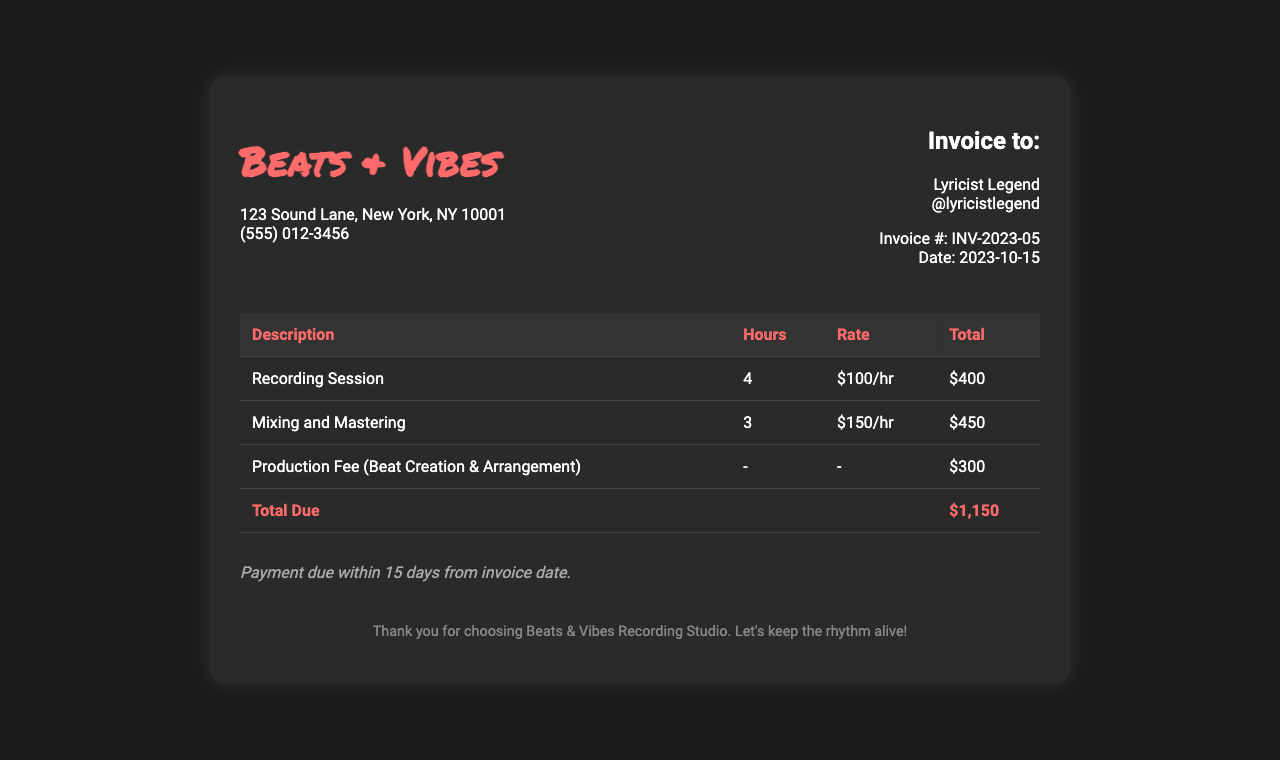What is the name of the studio? The name of the studio is located in the header section of the document.
Answer: Beats & Vibes Who is the invoice addressed to? The invoice recipient is mentioned in the client information section.
Answer: Lyricist Legend How many hours were booked for the recording session? The number of hours for the recording session is listed in the table under 'Hours'.
Answer: 4 What is the hourly rate for mixing and mastering? The rate is specified in the corresponding table cell for that service.
Answer: $150/hr What is the total amount due? The total due is calculated from all services rendered and is displayed clearly at the bottom of the invoice.
Answer: $1,150 What is the production fee for beat creation and arrangement? The production fee is listed in the 'Total' column for that service in the invoice.
Answer: $300 When is the payment due? The payment terms are outlined towards the end of the document detailing the due date.
Answer: 15 days from invoice date How many hours were allocated for mixing and mastering? The hours for mixing and mastering can be directly found in the invoice table under 'Hours'.
Answer: 3 What is the address of the recording studio? The studio's address can be found in the studio information section at the top of the document.
Answer: 123 Sound Lane, New York, NY 10001 